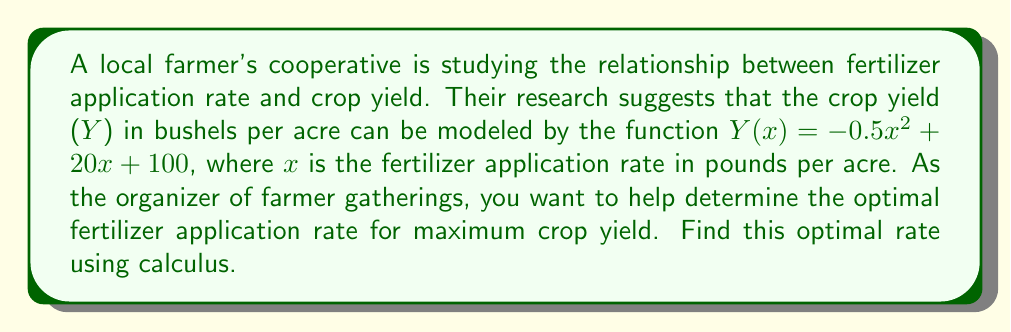Show me your answer to this math problem. To find the optimal fertilizer application rate for maximum crop yield, we need to follow these steps:

1) The function $Y(x) = -0.5x^2 + 20x + 100$ represents the crop yield.

2) To find the maximum of this function, we need to find where its derivative equals zero.

3) Let's calculate the derivative:
   $Y'(x) = \frac{d}{dx}(-0.5x^2 + 20x + 100)$
   $Y'(x) = -x + 20$

4) Set the derivative equal to zero and solve for x:
   $Y'(x) = 0$
   $-x + 20 = 0$
   $-x = -20$
   $x = 20$

5) To confirm this is a maximum (not a minimum), we can check the second derivative:
   $Y''(x) = \frac{d}{dx}(-x + 20) = -1$
   
   Since $Y''(x)$ is negative, this confirms we have a maximum at $x = 20$.

6) Therefore, the optimal fertilizer application rate is 20 pounds per acre.
Answer: 20 pounds per acre 